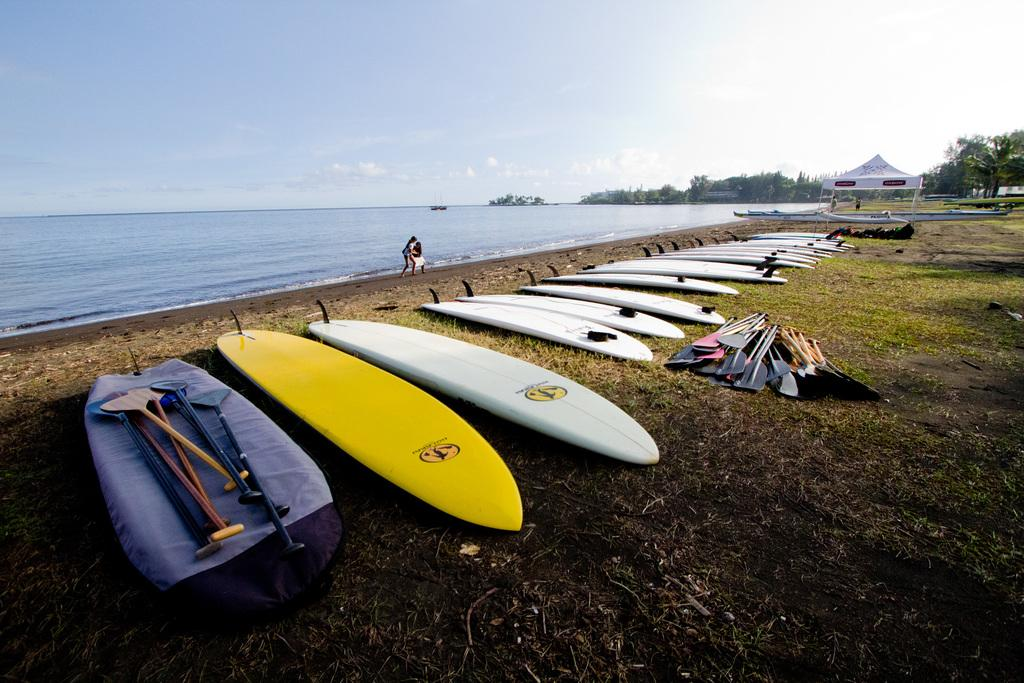What type of sports equipment can be seen in the image? There are surf boards and paddles in the image. Where are the surf boards and paddles located? The surf boards and paddles are on the grass ground. What type of shelter is present in the image? There is a tent in the image. What type of natural environment is visible in the image? There are trees and a beach in the image. What are the people in the image doing? The people in the image are walking at the seashore. How many cattle can be seen grazing on the grass in the image? There are no cattle present in the image; it features surf boards, paddles, a tent, trees, a beach, and people walking at the seashore. What type of material is used to make the wool in the image? There is no wool present in the image. 